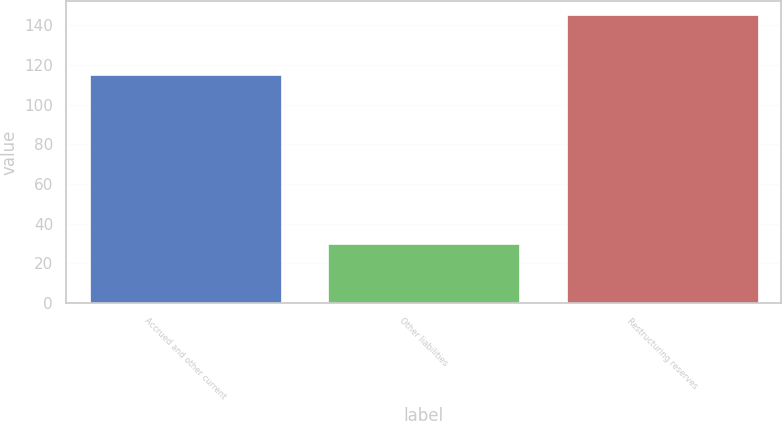Convert chart. <chart><loc_0><loc_0><loc_500><loc_500><bar_chart><fcel>Accrued and other current<fcel>Other liabilities<fcel>Restructuring reserves<nl><fcel>115<fcel>30<fcel>145<nl></chart> 